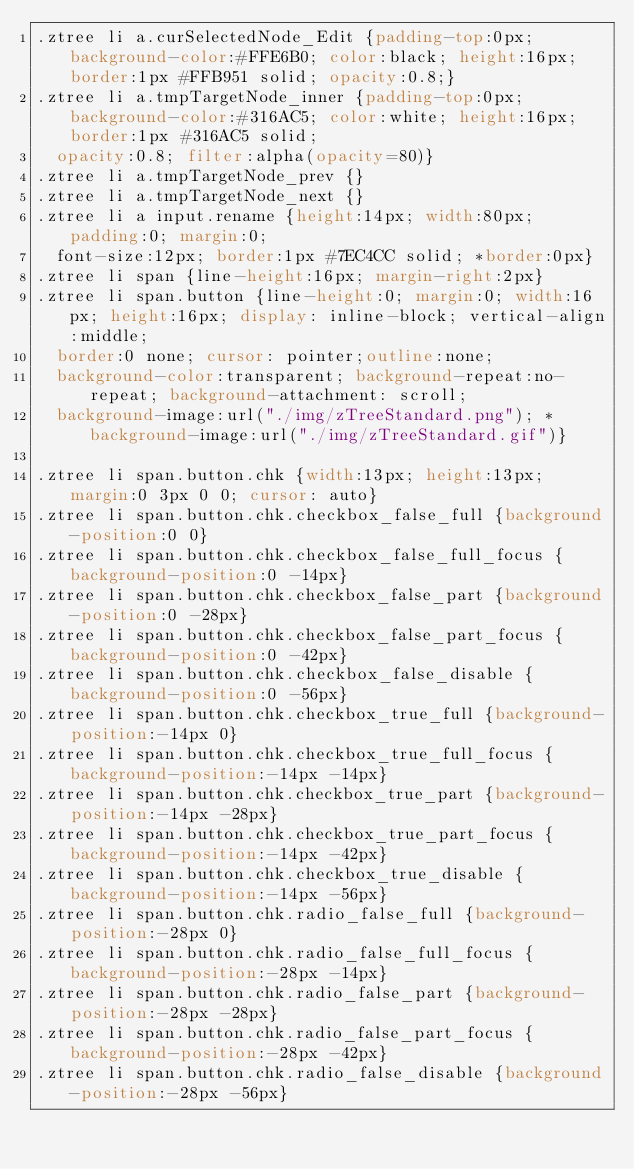<code> <loc_0><loc_0><loc_500><loc_500><_CSS_>.ztree li a.curSelectedNode_Edit {padding-top:0px; background-color:#FFE6B0; color:black; height:16px; border:1px #FFB951 solid; opacity:0.8;}
.ztree li a.tmpTargetNode_inner {padding-top:0px; background-color:#316AC5; color:white; height:16px; border:1px #316AC5 solid;
	opacity:0.8; filter:alpha(opacity=80)}
.ztree li a.tmpTargetNode_prev {}
.ztree li a.tmpTargetNode_next {}
.ztree li a input.rename {height:14px; width:80px; padding:0; margin:0;
	font-size:12px; border:1px #7EC4CC solid; *border:0px}
.ztree li span {line-height:16px; margin-right:2px}
.ztree li span.button {line-height:0; margin:0; width:16px; height:16px; display: inline-block; vertical-align:middle;
	border:0 none; cursor: pointer;outline:none;
	background-color:transparent; background-repeat:no-repeat; background-attachment: scroll;
	background-image:url("./img/zTreeStandard.png"); *background-image:url("./img/zTreeStandard.gif")}

.ztree li span.button.chk {width:13px; height:13px; margin:0 3px 0 0; cursor: auto}
.ztree li span.button.chk.checkbox_false_full {background-position:0 0}
.ztree li span.button.chk.checkbox_false_full_focus {background-position:0 -14px}
.ztree li span.button.chk.checkbox_false_part {background-position:0 -28px}
.ztree li span.button.chk.checkbox_false_part_focus {background-position:0 -42px}
.ztree li span.button.chk.checkbox_false_disable {background-position:0 -56px}
.ztree li span.button.chk.checkbox_true_full {background-position:-14px 0}
.ztree li span.button.chk.checkbox_true_full_focus {background-position:-14px -14px}
.ztree li span.button.chk.checkbox_true_part {background-position:-14px -28px}
.ztree li span.button.chk.checkbox_true_part_focus {background-position:-14px -42px}
.ztree li span.button.chk.checkbox_true_disable {background-position:-14px -56px}
.ztree li span.button.chk.radio_false_full {background-position:-28px 0}
.ztree li span.button.chk.radio_false_full_focus {background-position:-28px -14px}
.ztree li span.button.chk.radio_false_part {background-position:-28px -28px}
.ztree li span.button.chk.radio_false_part_focus {background-position:-28px -42px}
.ztree li span.button.chk.radio_false_disable {background-position:-28px -56px}</code> 